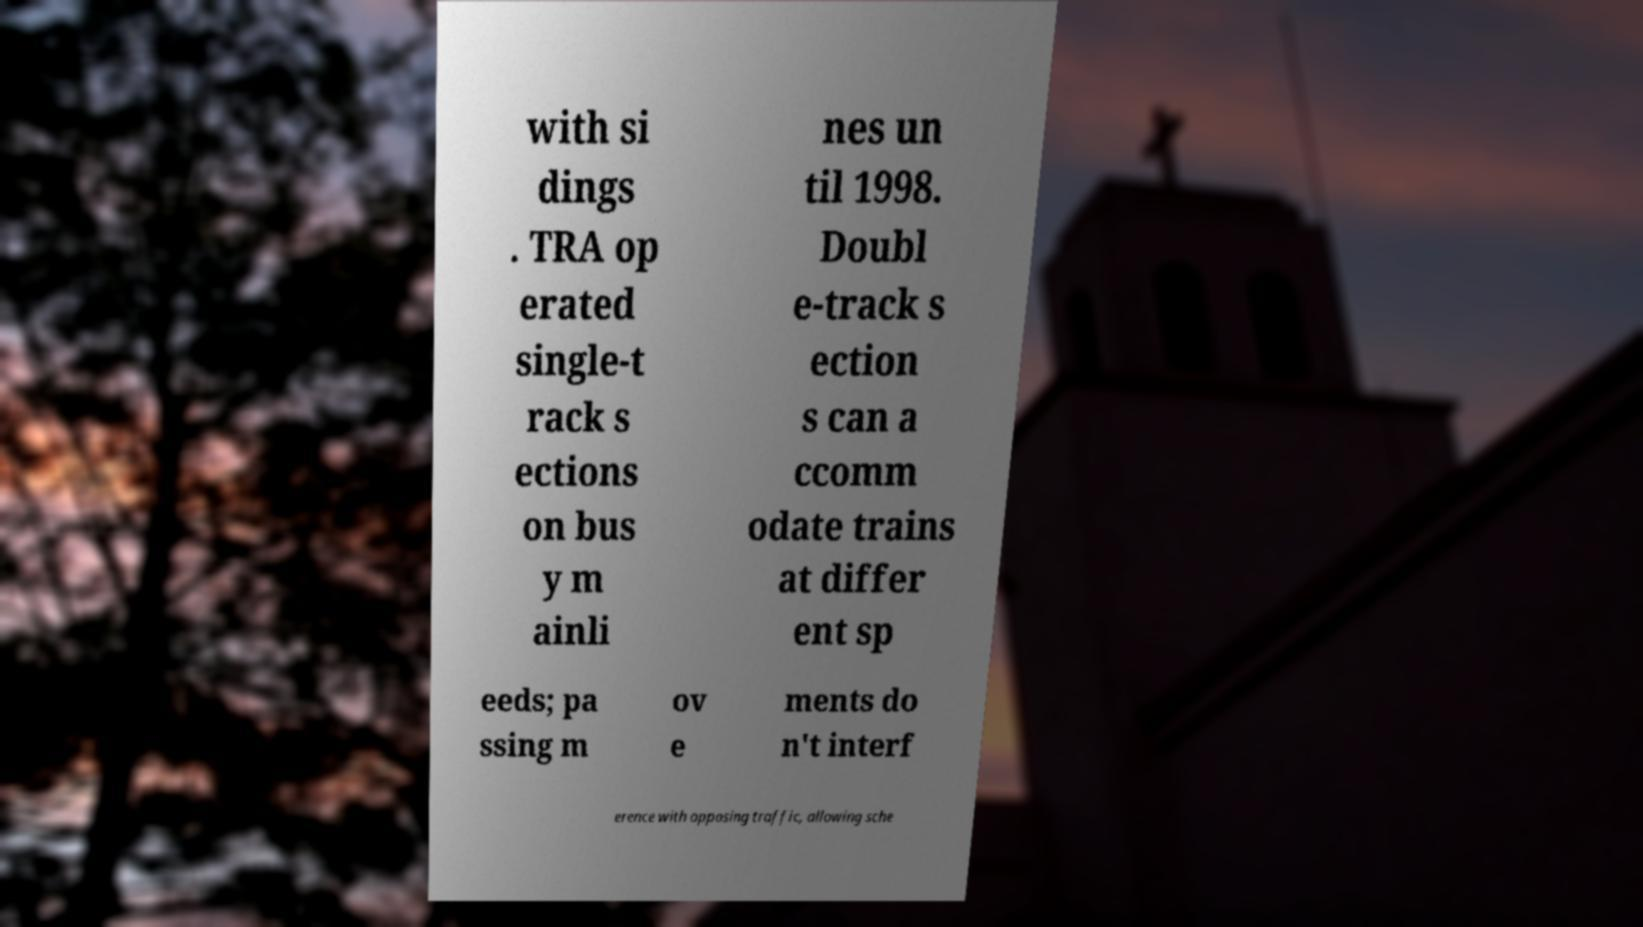For documentation purposes, I need the text within this image transcribed. Could you provide that? with si dings . TRA op erated single-t rack s ections on bus y m ainli nes un til 1998. Doubl e-track s ection s can a ccomm odate trains at differ ent sp eeds; pa ssing m ov e ments do n't interf erence with opposing traffic, allowing sche 